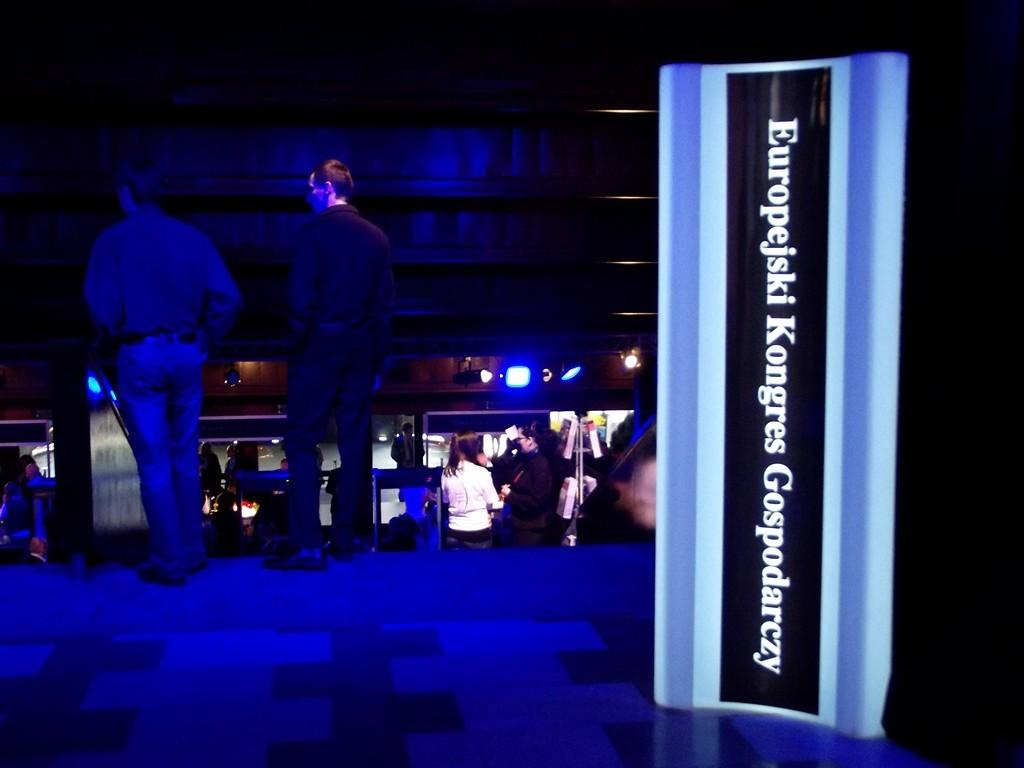What is the label on in the image? There is a label on an object in the image. Can you describe the people in the image? There are two men behind the label, and there are other people standing under the two men. What is the color of the lights in the image? Blue lights are fixed to the wall in the image. What type of fish can be seen swimming near the button in the image? There is no fish or button present in the image. How many sticks are being held by the people in the image? There is no mention of sticks being held by the people in the image. 